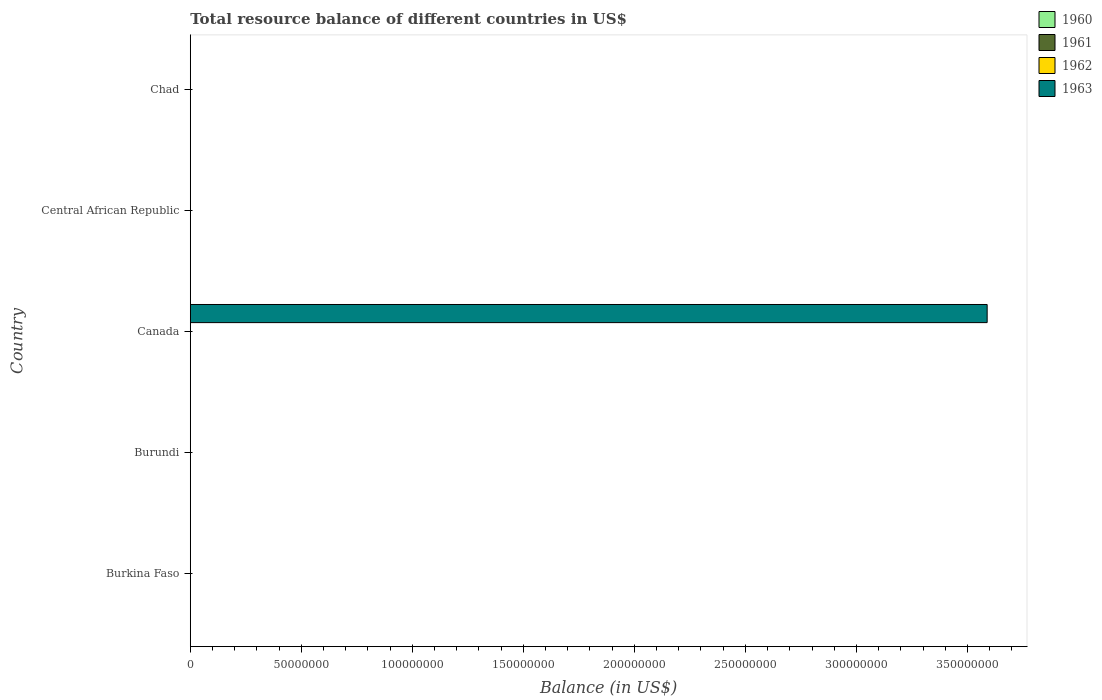How many different coloured bars are there?
Keep it short and to the point. 1. Are the number of bars per tick equal to the number of legend labels?
Offer a terse response. No. Are the number of bars on each tick of the Y-axis equal?
Your answer should be very brief. No. How many bars are there on the 2nd tick from the top?
Your answer should be very brief. 0. How many bars are there on the 3rd tick from the bottom?
Give a very brief answer. 1. What is the label of the 4th group of bars from the top?
Keep it short and to the point. Burundi. In how many cases, is the number of bars for a given country not equal to the number of legend labels?
Offer a very short reply. 5. Across all countries, what is the maximum total resource balance in 1963?
Your answer should be compact. 3.59e+08. In how many countries, is the total resource balance in 1963 greater than 340000000 US$?
Your answer should be compact. 1. What is the difference between the highest and the lowest total resource balance in 1963?
Your response must be concise. 3.59e+08. How many bars are there?
Provide a succinct answer. 1. Are all the bars in the graph horizontal?
Your response must be concise. Yes. What is the difference between two consecutive major ticks on the X-axis?
Give a very brief answer. 5.00e+07. Where does the legend appear in the graph?
Offer a terse response. Top right. What is the title of the graph?
Make the answer very short. Total resource balance of different countries in US$. Does "1975" appear as one of the legend labels in the graph?
Provide a short and direct response. No. What is the label or title of the X-axis?
Provide a succinct answer. Balance (in US$). What is the label or title of the Y-axis?
Your response must be concise. Country. What is the Balance (in US$) in 1960 in Burkina Faso?
Your answer should be compact. 0. What is the Balance (in US$) of 1962 in Burkina Faso?
Ensure brevity in your answer.  0. What is the Balance (in US$) of 1963 in Burkina Faso?
Offer a terse response. 0. What is the Balance (in US$) of 1960 in Burundi?
Your answer should be very brief. 0. What is the Balance (in US$) in 1961 in Canada?
Provide a succinct answer. 0. What is the Balance (in US$) of 1962 in Canada?
Give a very brief answer. 0. What is the Balance (in US$) in 1963 in Canada?
Your answer should be very brief. 3.59e+08. What is the Balance (in US$) in 1961 in Central African Republic?
Offer a terse response. 0. What is the Balance (in US$) of 1963 in Central African Republic?
Ensure brevity in your answer.  0. What is the Balance (in US$) in 1960 in Chad?
Your answer should be very brief. 0. What is the Balance (in US$) of 1962 in Chad?
Your answer should be very brief. 0. What is the Balance (in US$) of 1963 in Chad?
Make the answer very short. 0. Across all countries, what is the maximum Balance (in US$) of 1963?
Your response must be concise. 3.59e+08. Across all countries, what is the minimum Balance (in US$) of 1963?
Your answer should be very brief. 0. What is the total Balance (in US$) of 1960 in the graph?
Ensure brevity in your answer.  0. What is the total Balance (in US$) of 1961 in the graph?
Provide a short and direct response. 0. What is the total Balance (in US$) in 1963 in the graph?
Offer a very short reply. 3.59e+08. What is the average Balance (in US$) of 1961 per country?
Keep it short and to the point. 0. What is the average Balance (in US$) in 1963 per country?
Make the answer very short. 7.18e+07. What is the difference between the highest and the lowest Balance (in US$) of 1963?
Your answer should be compact. 3.59e+08. 